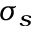<formula> <loc_0><loc_0><loc_500><loc_500>\sigma _ { s }</formula> 